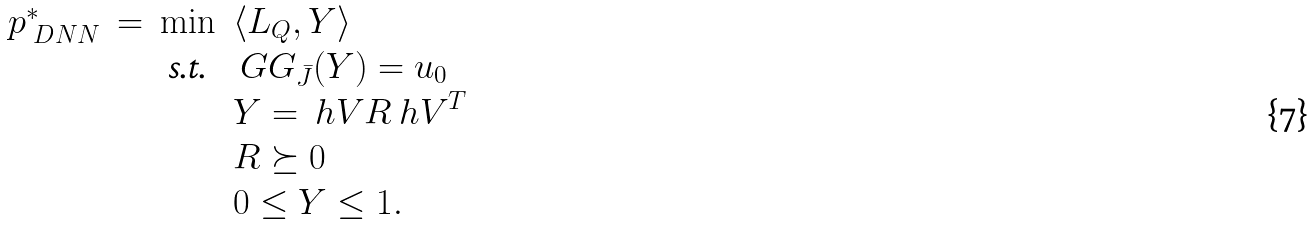Convert formula to latex. <formula><loc_0><loc_0><loc_500><loc_500>\begin{array} { r c c l } p _ { \ D N N } ^ { * } & = & \min & \langle L _ { Q } , Y \rangle \\ & & \text {s.t.} & \ G G _ { \bar { J } } ( Y ) = u _ { 0 } \\ & & & Y = { \ h V } R { \ h V } ^ { T } \\ & & & R \succeq 0 \\ & & & 0 \leq Y \leq 1 . \end{array}</formula> 